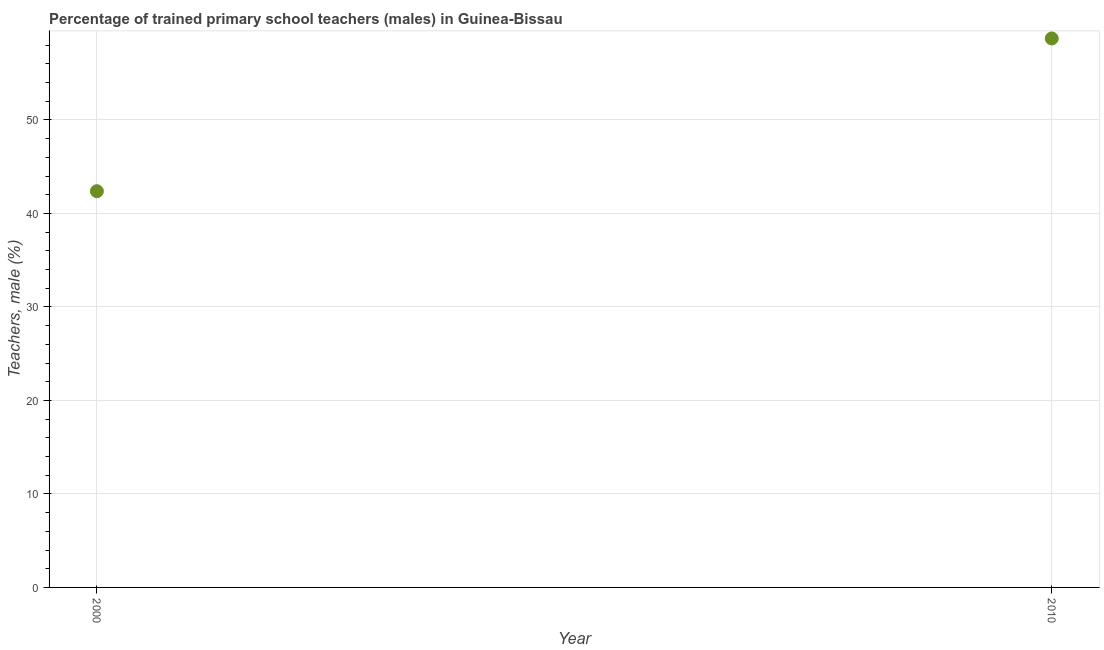What is the percentage of trained male teachers in 2010?
Offer a very short reply. 58.72. Across all years, what is the maximum percentage of trained male teachers?
Provide a succinct answer. 58.72. Across all years, what is the minimum percentage of trained male teachers?
Offer a very short reply. 42.38. In which year was the percentage of trained male teachers minimum?
Provide a short and direct response. 2000. What is the sum of the percentage of trained male teachers?
Offer a terse response. 101.1. What is the difference between the percentage of trained male teachers in 2000 and 2010?
Make the answer very short. -16.34. What is the average percentage of trained male teachers per year?
Your answer should be very brief. 50.55. What is the median percentage of trained male teachers?
Provide a short and direct response. 50.55. In how many years, is the percentage of trained male teachers greater than 46 %?
Your answer should be compact. 1. What is the ratio of the percentage of trained male teachers in 2000 to that in 2010?
Offer a terse response. 0.72. Is the percentage of trained male teachers in 2000 less than that in 2010?
Make the answer very short. Yes. In how many years, is the percentage of trained male teachers greater than the average percentage of trained male teachers taken over all years?
Your answer should be compact. 1. Does the percentage of trained male teachers monotonically increase over the years?
Offer a very short reply. Yes. How many dotlines are there?
Offer a terse response. 1. What is the difference between two consecutive major ticks on the Y-axis?
Provide a short and direct response. 10. Does the graph contain any zero values?
Offer a terse response. No. What is the title of the graph?
Offer a terse response. Percentage of trained primary school teachers (males) in Guinea-Bissau. What is the label or title of the Y-axis?
Make the answer very short. Teachers, male (%). What is the Teachers, male (%) in 2000?
Give a very brief answer. 42.38. What is the Teachers, male (%) in 2010?
Your answer should be very brief. 58.72. What is the difference between the Teachers, male (%) in 2000 and 2010?
Keep it short and to the point. -16.34. What is the ratio of the Teachers, male (%) in 2000 to that in 2010?
Give a very brief answer. 0.72. 